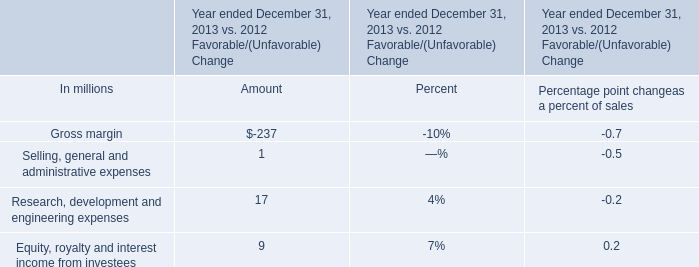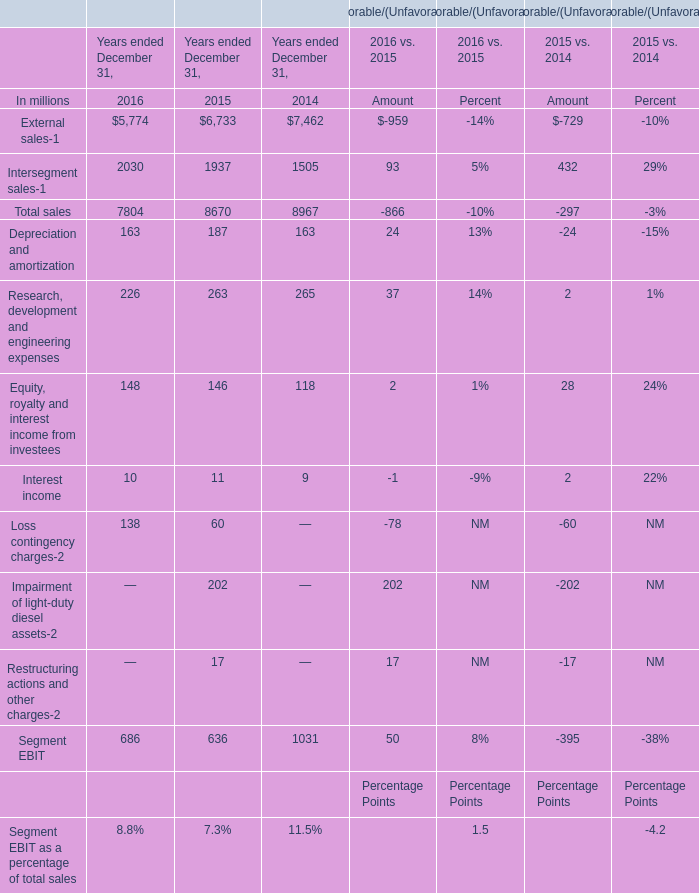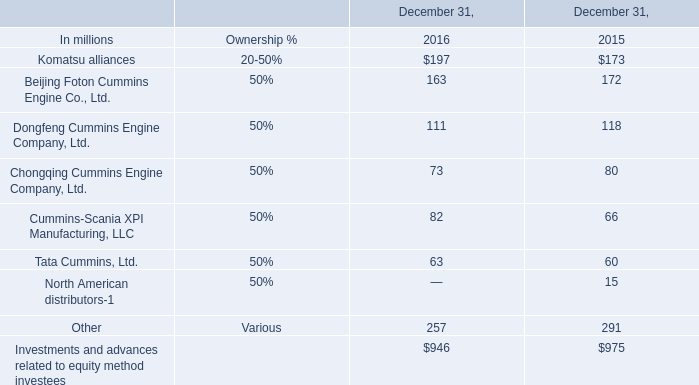If Total sales develops with the same increasing rate in 2016, what will it reach in 2017? (in million) 
Computations: (7804 * (1 + ((7804 - 8670) / 8670)))
Answer: 7024.50012. 